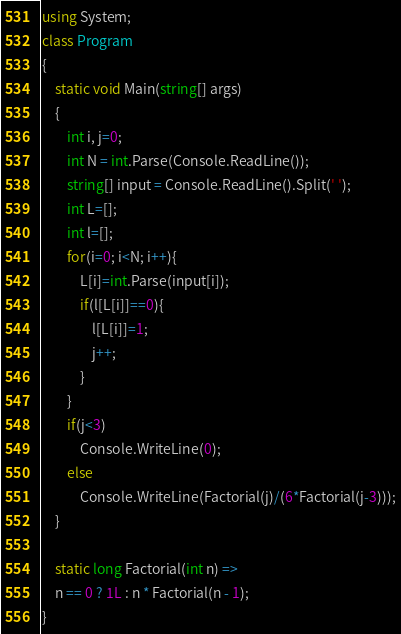<code> <loc_0><loc_0><loc_500><loc_500><_C#_>using System;
class Program
{
    static void Main(string[] args)
    {
        int i, j=0;
        int N = int.Parse(Console.ReadLine());
        string[] input = Console.ReadLine().Split(' ');
        int L=[];
        int l=[];
        for(i=0; i<N; i++){
            L[i]=int.Parse(input[i]);
            if(l[L[i]]==0){
                l[L[i]]=1;
                j++;
            }
        }
        if(j<3)
            Console.WriteLine(0);
        else
            Console.WriteLine(Factorial(j)/(6*Factorial(j-3)));
    }

    static long Factorial(int n) =>
    n == 0 ? 1L : n * Factorial(n - 1);
}</code> 